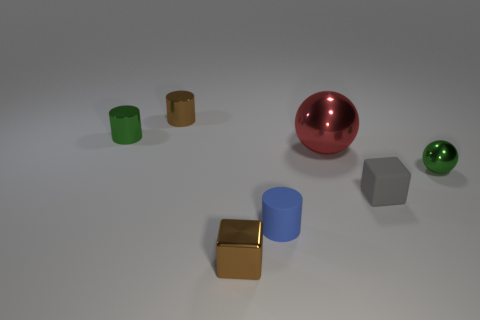Can you describe the different objects in the image and what materials they might be made of? In the image, there is a collection of objects with various shapes and colors. Starting from the left, there are two cylinders, one green and one blue, which might be made of a matte plastic due to their opaque surfaces. Next is a golden cube with a reflective surface that could be either a polished metal or a metallic paint finish over plastic. Behind it, a smaller brown cylindrical object is visible with a similar matte finish, suggesting it may also be plastic. In the center is a large, glossy red sphere, likely made of a polished metal judging by its reflective quality. Finally, there is a small, shiny green sphere and a gray hexagon, both with surfaces suggesting a metallic makeup, perhaps stainless steel for the hexagon and painted metal for the green sphere. 